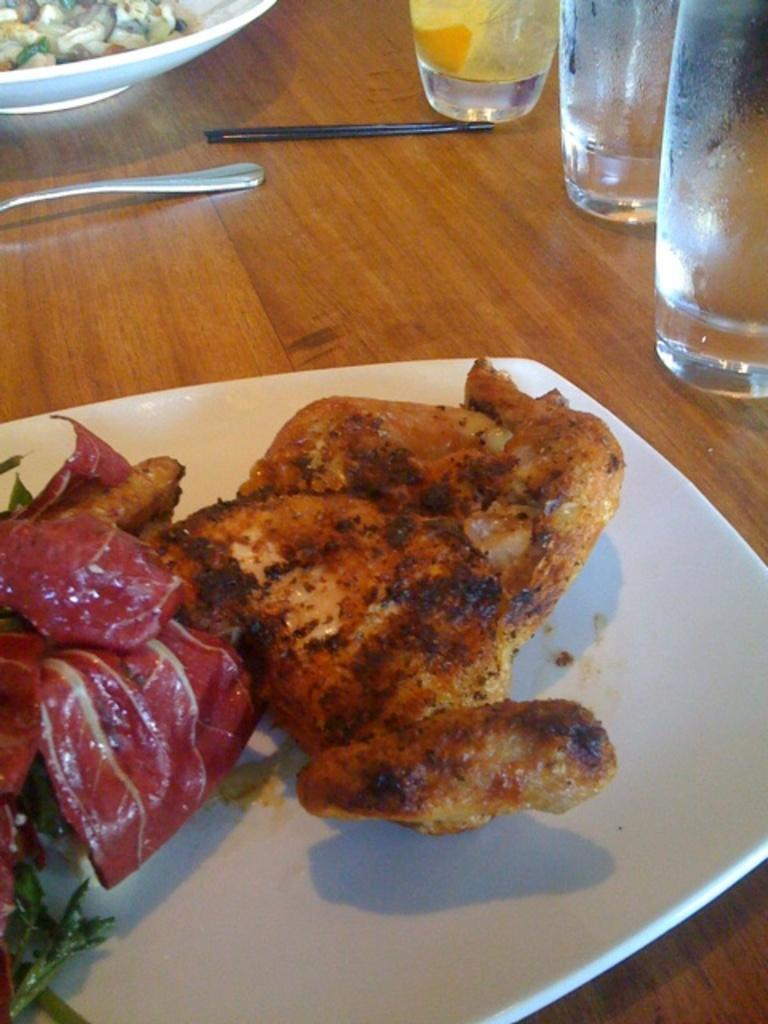How many plates can be seen in the image? There are two white color plates in the image. What is on the plates? Food is present on the plates. What else can be seen on the table besides the plates? There are glasses and spoons in the image. What is the color of the table? The table is brown in color. What type of pollution is visible in the image? There is no pollution visible in the image; it features plates with food, glasses, and spoons on a brown table. 